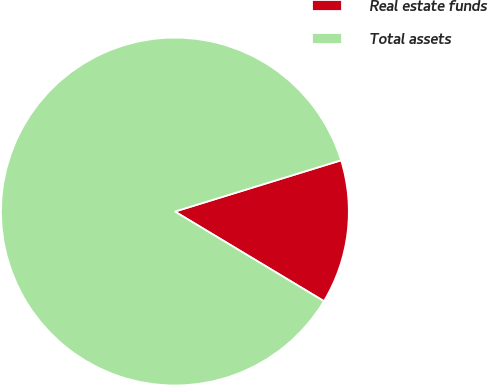Convert chart to OTSL. <chart><loc_0><loc_0><loc_500><loc_500><pie_chart><fcel>Real estate funds<fcel>Total assets<nl><fcel>13.38%<fcel>86.62%<nl></chart> 